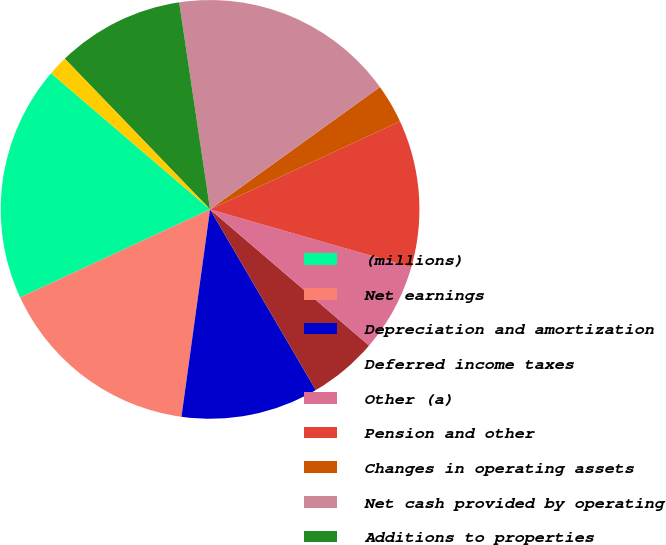<chart> <loc_0><loc_0><loc_500><loc_500><pie_chart><fcel>(millions)<fcel>Net earnings<fcel>Depreciation and amortization<fcel>Deferred income taxes<fcel>Other (a)<fcel>Pension and other<fcel>Changes in operating assets<fcel>Net cash provided by operating<fcel>Additions to properties<fcel>Property disposals<nl><fcel>18.18%<fcel>15.91%<fcel>10.61%<fcel>5.3%<fcel>6.82%<fcel>11.36%<fcel>3.03%<fcel>17.42%<fcel>9.85%<fcel>1.52%<nl></chart> 